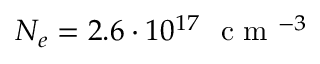<formula> <loc_0><loc_0><loc_500><loc_500>N _ { e } = 2 . 6 \cdot 1 0 ^ { 1 7 } c m ^ { - 3 }</formula> 